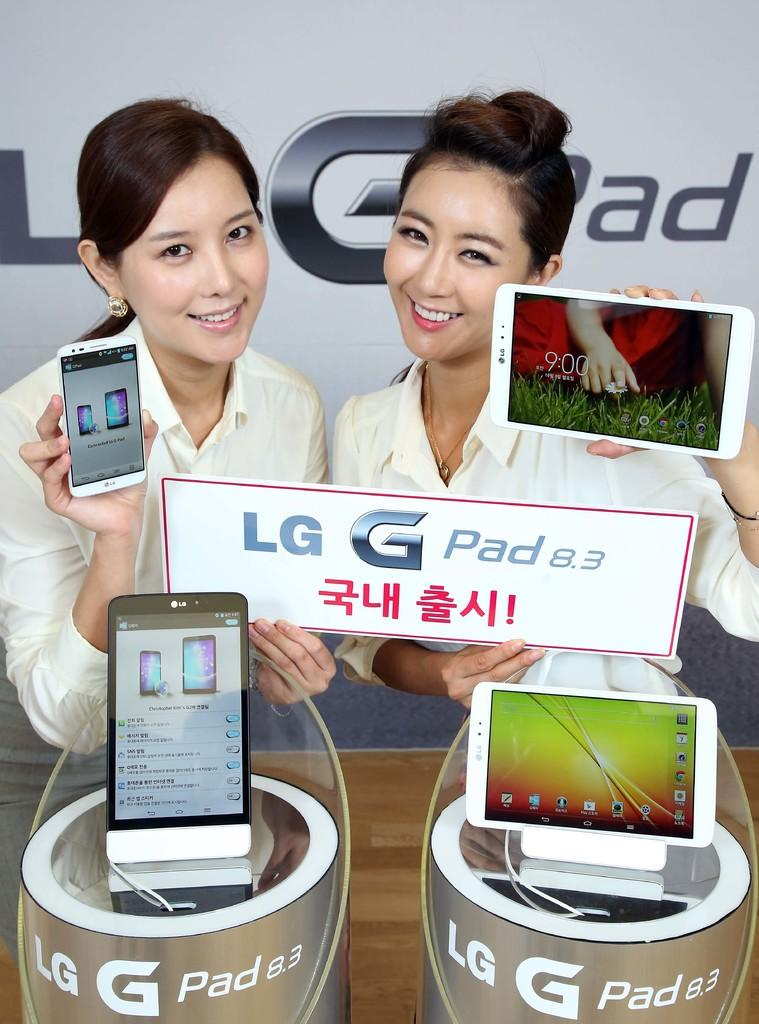<image>
Present a compact description of the photo's key features. Two women holding different size devices as the hold a sign that reads LG G Pad 8.3 